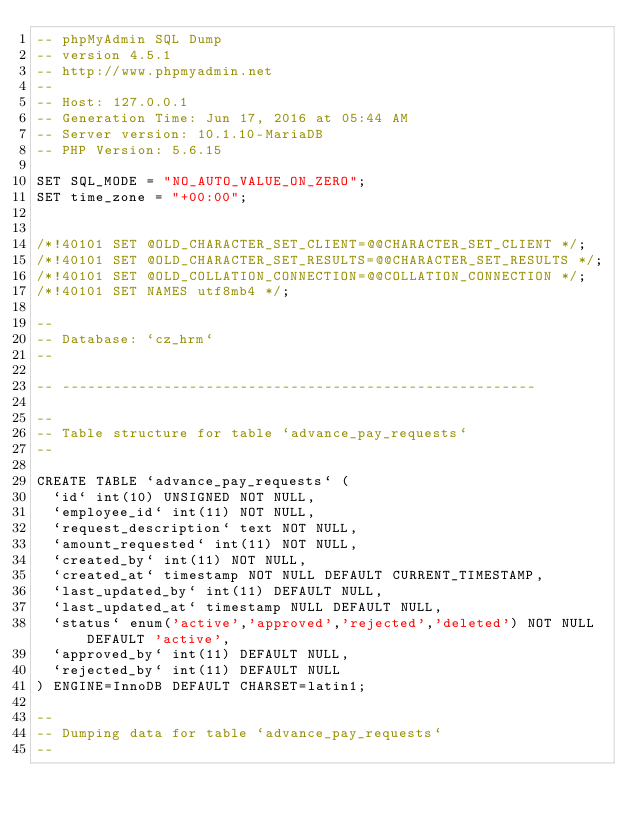Convert code to text. <code><loc_0><loc_0><loc_500><loc_500><_SQL_>-- phpMyAdmin SQL Dump
-- version 4.5.1
-- http://www.phpmyadmin.net
--
-- Host: 127.0.0.1
-- Generation Time: Jun 17, 2016 at 05:44 AM
-- Server version: 10.1.10-MariaDB
-- PHP Version: 5.6.15

SET SQL_MODE = "NO_AUTO_VALUE_ON_ZERO";
SET time_zone = "+00:00";


/*!40101 SET @OLD_CHARACTER_SET_CLIENT=@@CHARACTER_SET_CLIENT */;
/*!40101 SET @OLD_CHARACTER_SET_RESULTS=@@CHARACTER_SET_RESULTS */;
/*!40101 SET @OLD_COLLATION_CONNECTION=@@COLLATION_CONNECTION */;
/*!40101 SET NAMES utf8mb4 */;

--
-- Database: `cz_hrm`
--

-- --------------------------------------------------------

--
-- Table structure for table `advance_pay_requests`
--

CREATE TABLE `advance_pay_requests` (
  `id` int(10) UNSIGNED NOT NULL,
  `employee_id` int(11) NOT NULL,
  `request_description` text NOT NULL,
  `amount_requested` int(11) NOT NULL,
  `created_by` int(11) NOT NULL,
  `created_at` timestamp NOT NULL DEFAULT CURRENT_TIMESTAMP,
  `last_updated_by` int(11) DEFAULT NULL,
  `last_updated_at` timestamp NULL DEFAULT NULL,
  `status` enum('active','approved','rejected','deleted') NOT NULL DEFAULT 'active',
  `approved_by` int(11) DEFAULT NULL,
  `rejected_by` int(11) DEFAULT NULL
) ENGINE=InnoDB DEFAULT CHARSET=latin1;

--
-- Dumping data for table `advance_pay_requests`
--
</code> 